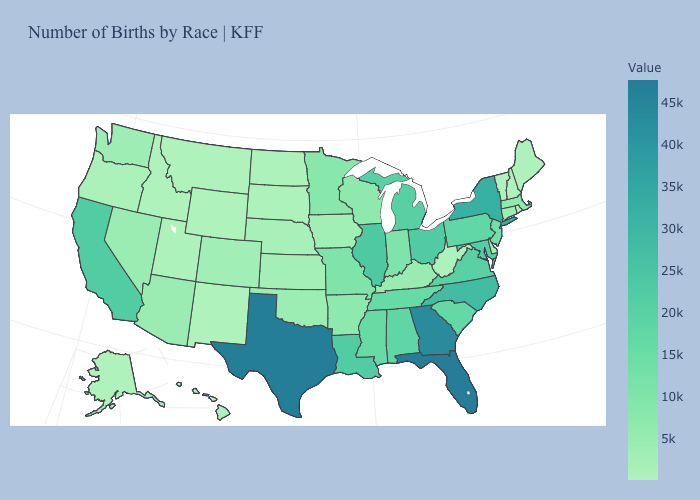Does the map have missing data?
Answer briefly. No. Is the legend a continuous bar?
Answer briefly. Yes. Among the states that border Minnesota , does South Dakota have the lowest value?
Answer briefly. Yes. Does South Dakota have the lowest value in the MidWest?
Short answer required. Yes. 